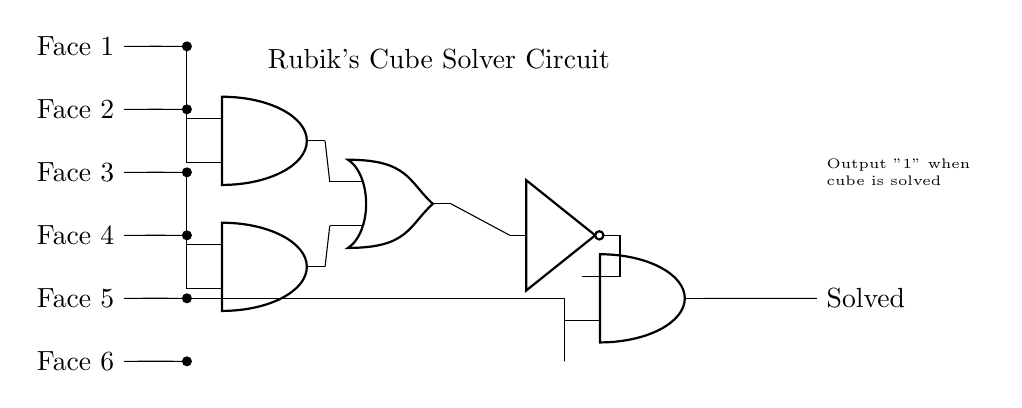What is the output of the circuit? The output of the circuit is labeled "Solved," indicating whether the Rubik's Cube is solved based on the input conditions.
Answer: Solved How many AND gates are present in the circuit? There are three AND gates in the circuit, which are specifically labeled as AND1, AND2, and AND3 in the diagram.
Answer: Three What is the function of the NOT gate in this circuit? The NOT gate inverts the output of the OR gate, providing a logical negation, which is crucial for determining the final output of the Rubik's Cube solver.
Answer: Inversion Which two faces are inputs to the first AND gate? The inputs to the first AND gate (AND1) are provided from Face 1 and Face 2, as indicated by the connections in the circuit diagram.
Answer: Face 1 and Face 2 How many input signals are connected to the OR gate? The OR gate receives inputs from two AND gates, specifically AND1 and AND2, making a total of two inputs connected to it.
Answer: Two What is the purpose of the OR gate in this circuit? The OR gate combines the outputs of the two AND gates (AND1 and AND2) to determine if at least one condition is met, contributing to the logical decision-making of the Rubik's Cube solver.
Answer: Combination 